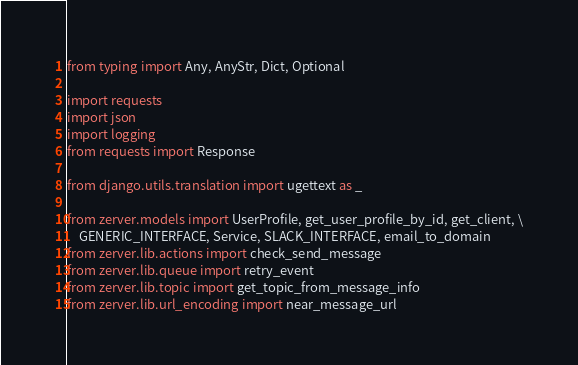<code> <loc_0><loc_0><loc_500><loc_500><_Python_>from typing import Any, AnyStr, Dict, Optional

import requests
import json
import logging
from requests import Response

from django.utils.translation import ugettext as _

from zerver.models import UserProfile, get_user_profile_by_id, get_client, \
    GENERIC_INTERFACE, Service, SLACK_INTERFACE, email_to_domain
from zerver.lib.actions import check_send_message
from zerver.lib.queue import retry_event
from zerver.lib.topic import get_topic_from_message_info
from zerver.lib.url_encoding import near_message_url</code> 